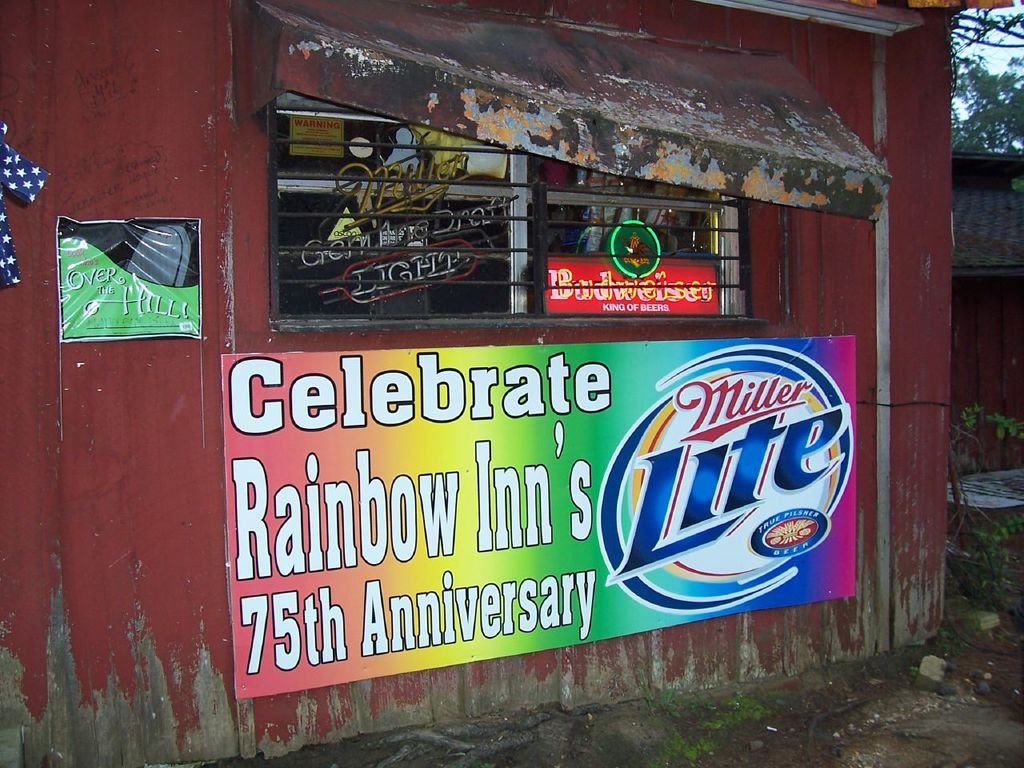What does the presence of the American flag and neon signs suggest about this location? The American flag denotes a sense of patriotism and local pride, common in many American small businesses and community hubs. The array of neon signs, particularly the beer brands, hints at the inn being a popular social gathering place, likely frequented by locals and visitors alike. These elements suggest a venue that values both its national identity and its role as a lively, welcoming spot for socialization and celebration. 